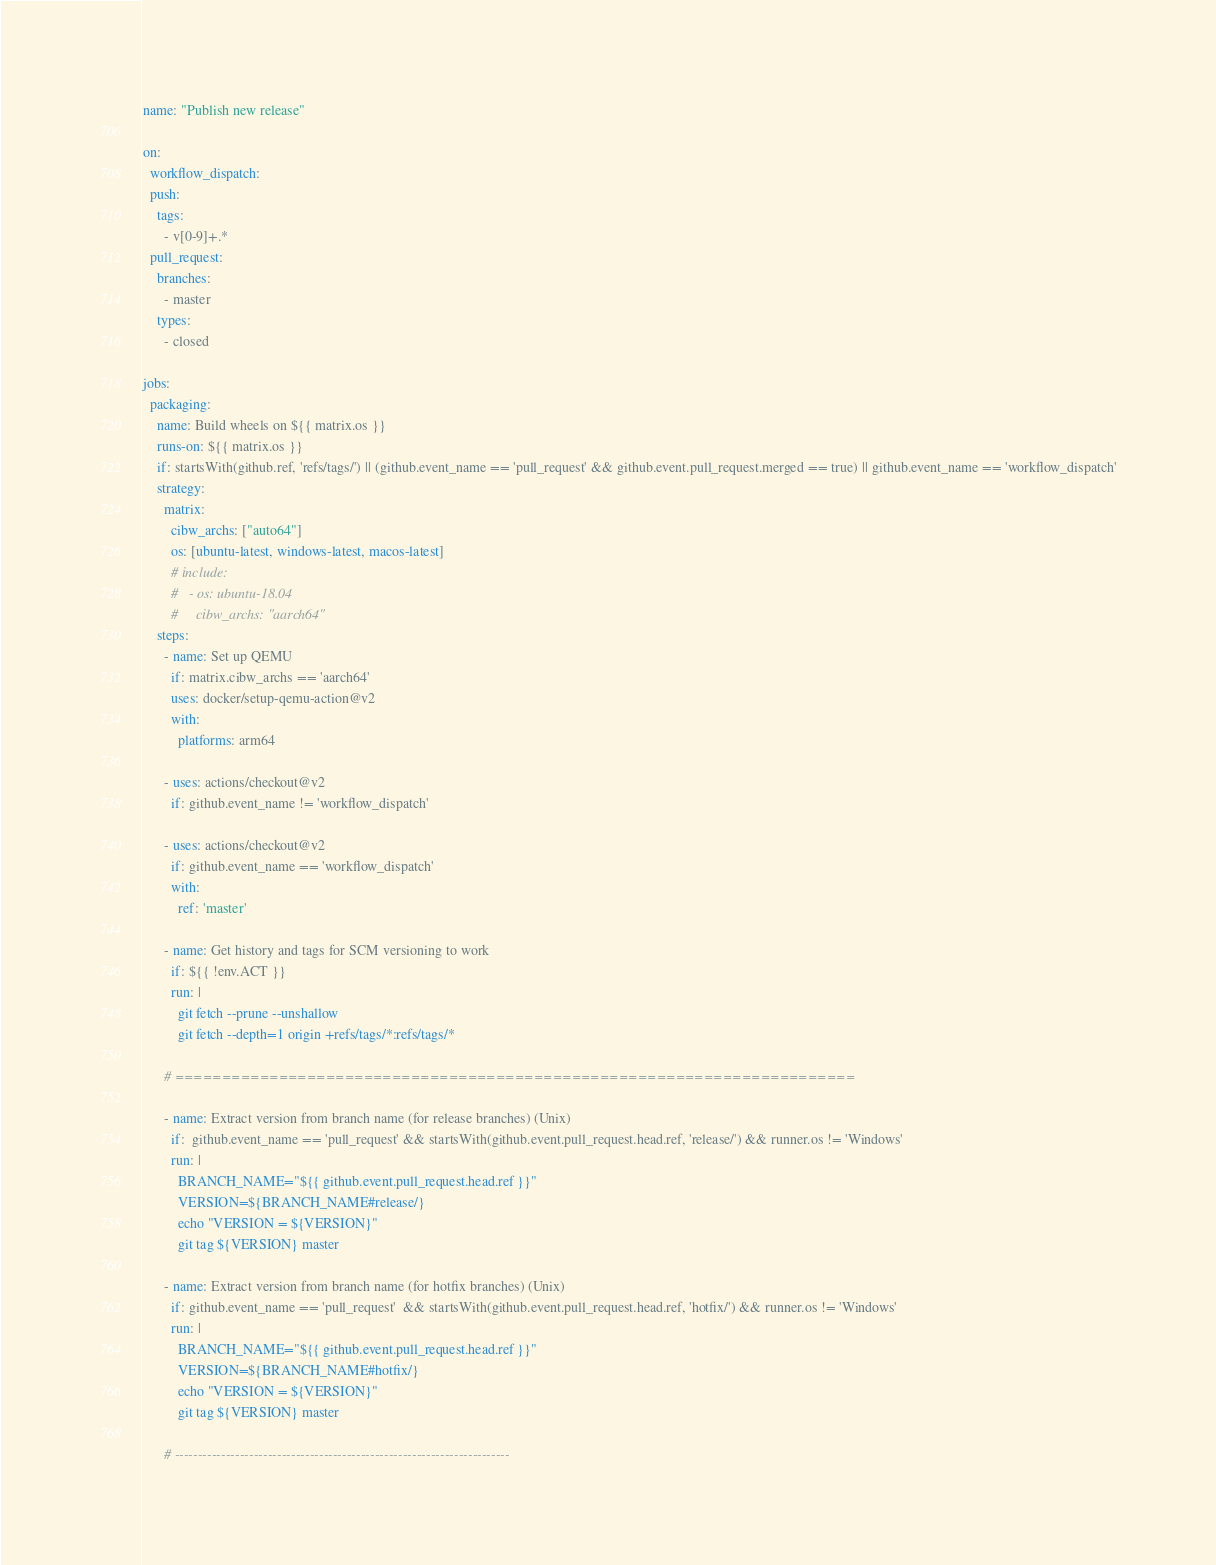<code> <loc_0><loc_0><loc_500><loc_500><_YAML_>name: "Publish new release"

on:
  workflow_dispatch:
  push:
    tags:
      - v[0-9]+.*
  pull_request:
    branches:
      - master
    types:
      - closed

jobs:
  packaging:
    name: Build wheels on ${{ matrix.os }}
    runs-on: ${{ matrix.os }}
    if: startsWith(github.ref, 'refs/tags/') || (github.event_name == 'pull_request' && github.event.pull_request.merged == true) || github.event_name == 'workflow_dispatch'
    strategy:
      matrix:
        cibw_archs: ["auto64"]
        os: [ubuntu-latest, windows-latest, macos-latest]
        # include:
        #   - os: ubuntu-18.04
        #     cibw_archs: "aarch64"
    steps:
      - name: Set up QEMU
        if: matrix.cibw_archs == 'aarch64'
        uses: docker/setup-qemu-action@v2
        with:
          platforms: arm64

      - uses: actions/checkout@v2
        if: github.event_name != 'workflow_dispatch'

      - uses: actions/checkout@v2
        if: github.event_name == 'workflow_dispatch'
        with:
          ref: 'master'

      - name: Get history and tags for SCM versioning to work
        if: ${{ !env.ACT }}
        run: |
          git fetch --prune --unshallow
          git fetch --depth=1 origin +refs/tags/*:refs/tags/*

      # ========================================================================

      - name: Extract version from branch name (for release branches) (Unix)
        if:  github.event_name == 'pull_request' && startsWith(github.event.pull_request.head.ref, 'release/') && runner.os != 'Windows'
        run: |
          BRANCH_NAME="${{ github.event.pull_request.head.ref }}"
          VERSION=${BRANCH_NAME#release/}
          echo "VERSION = ${VERSION}"
          git tag ${VERSION} master

      - name: Extract version from branch name (for hotfix branches) (Unix)
        if: github.event_name == 'pull_request'  && startsWith(github.event.pull_request.head.ref, 'hotfix/') && runner.os != 'Windows'
        run: |
          BRANCH_NAME="${{ github.event.pull_request.head.ref }}"
          VERSION=${BRANCH_NAME#hotfix/}
          echo "VERSION = ${VERSION}"
          git tag ${VERSION} master

      # ------------------------------------------------------------------------
</code> 